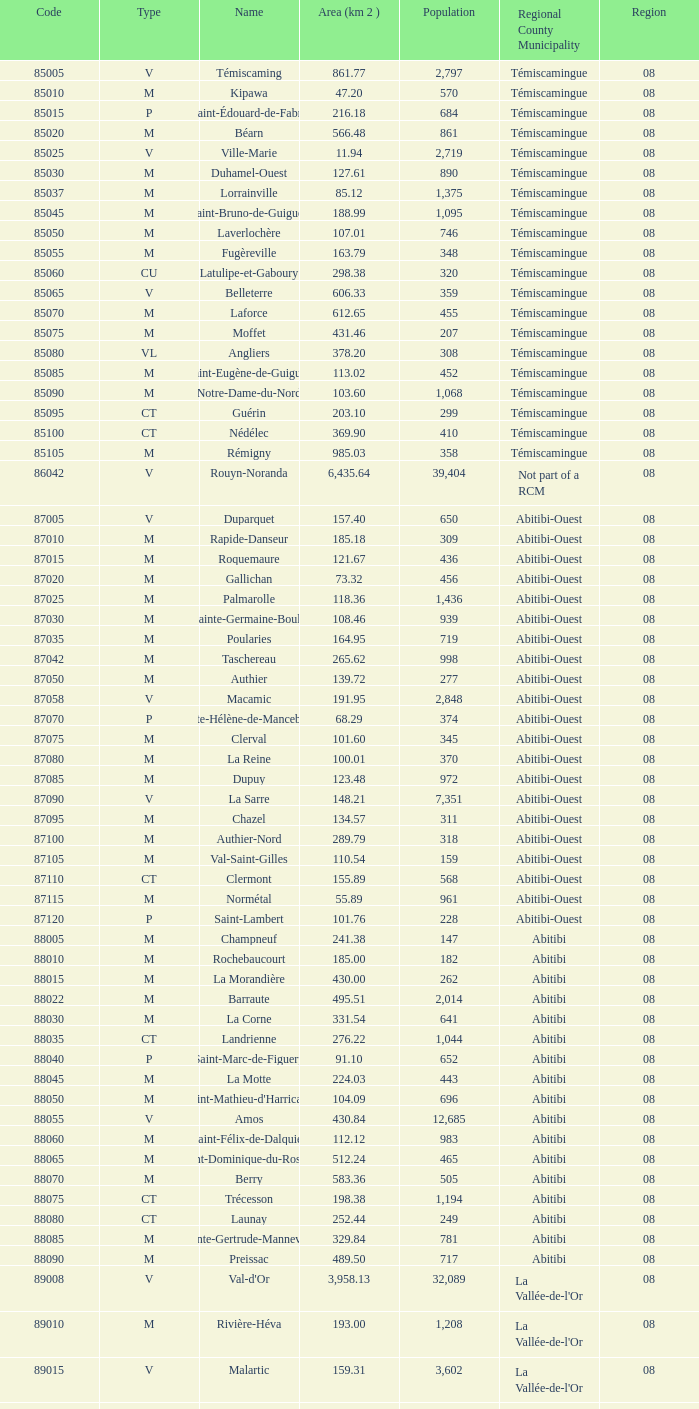In which type can you find a total of 370 members? M. 